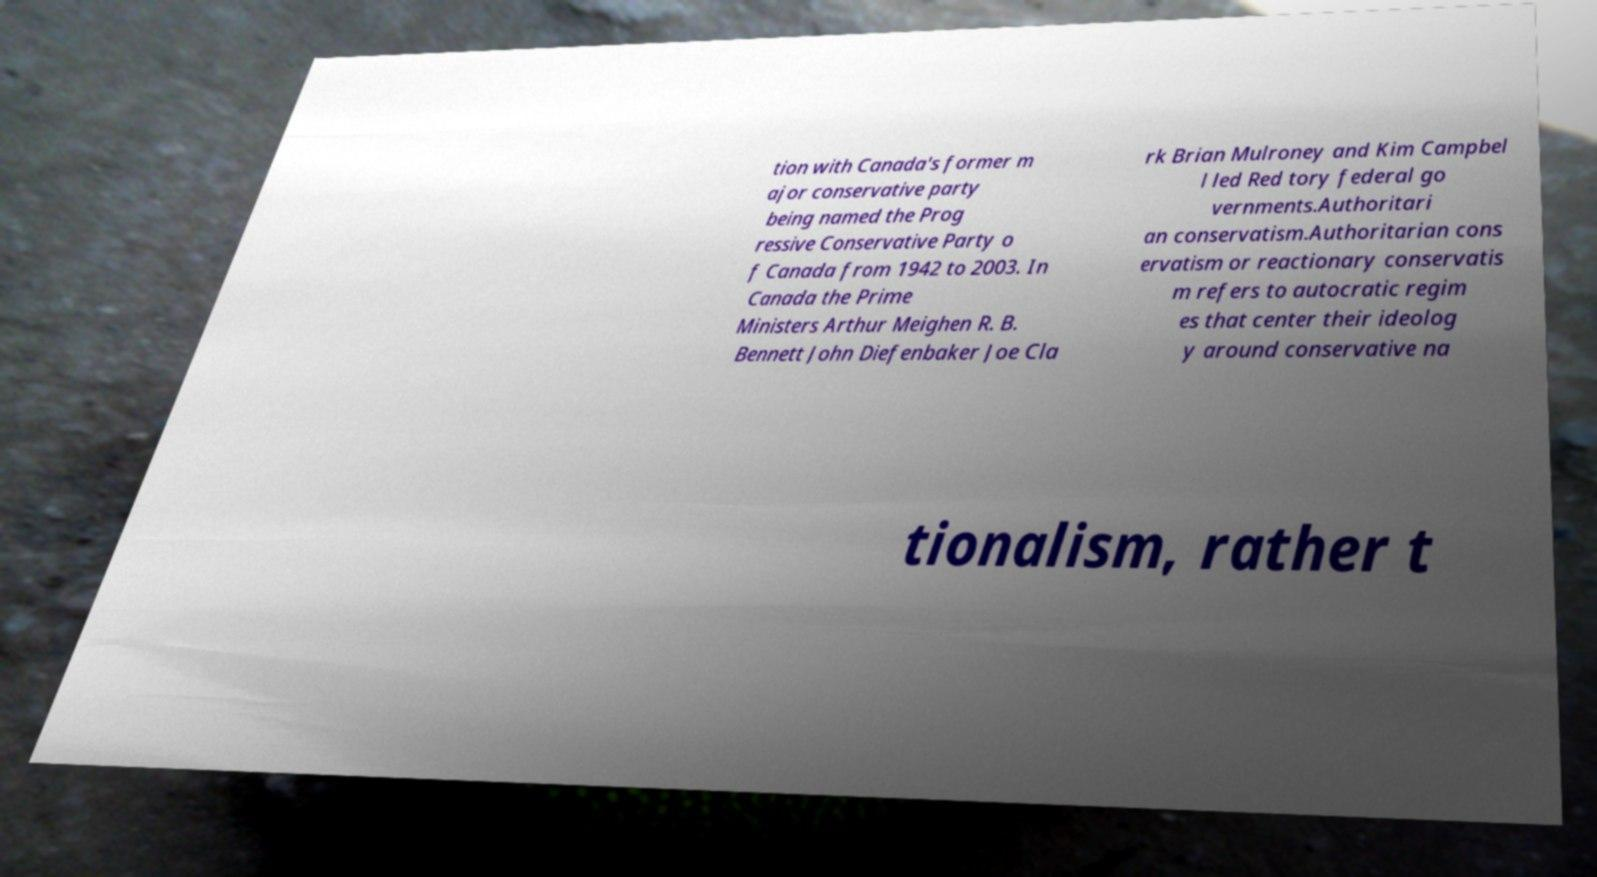What messages or text are displayed in this image? I need them in a readable, typed format. tion with Canada's former m ajor conservative party being named the Prog ressive Conservative Party o f Canada from 1942 to 2003. In Canada the Prime Ministers Arthur Meighen R. B. Bennett John Diefenbaker Joe Cla rk Brian Mulroney and Kim Campbel l led Red tory federal go vernments.Authoritari an conservatism.Authoritarian cons ervatism or reactionary conservatis m refers to autocratic regim es that center their ideolog y around conservative na tionalism, rather t 